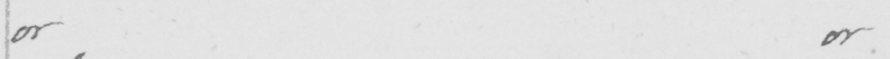Can you read and transcribe this handwriting? or or 